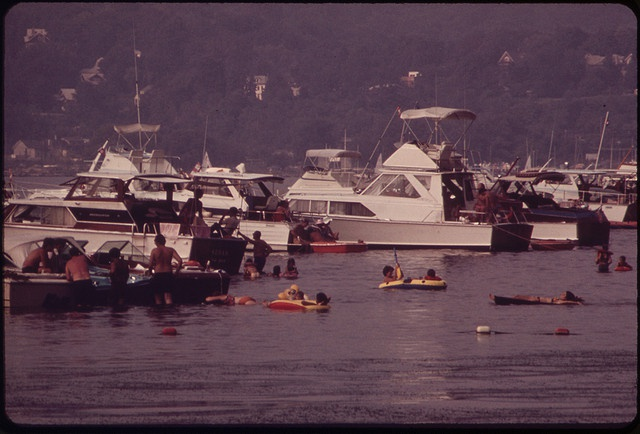Describe the objects in this image and their specific colors. I can see boat in black, tan, gray, and darkgray tones, boat in black, gray, purple, and brown tones, boat in black, brown, maroon, and tan tones, people in black, brown, and maroon tones, and boat in black, gray, and maroon tones in this image. 